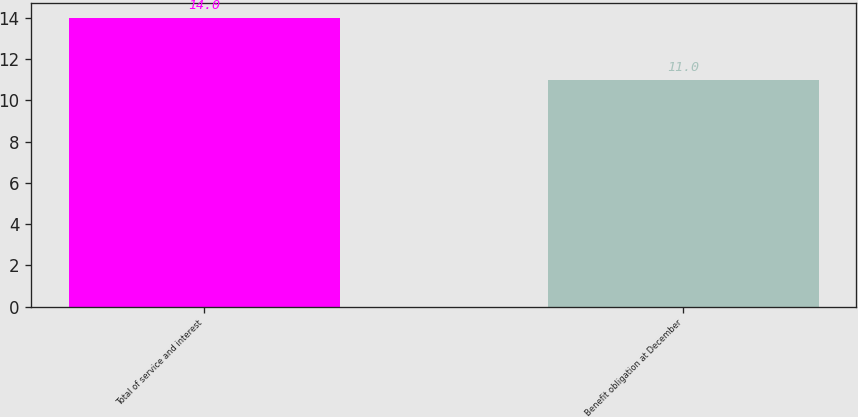Convert chart to OTSL. <chart><loc_0><loc_0><loc_500><loc_500><bar_chart><fcel>Total of service and interest<fcel>Benefit obligation at December<nl><fcel>14<fcel>11<nl></chart> 